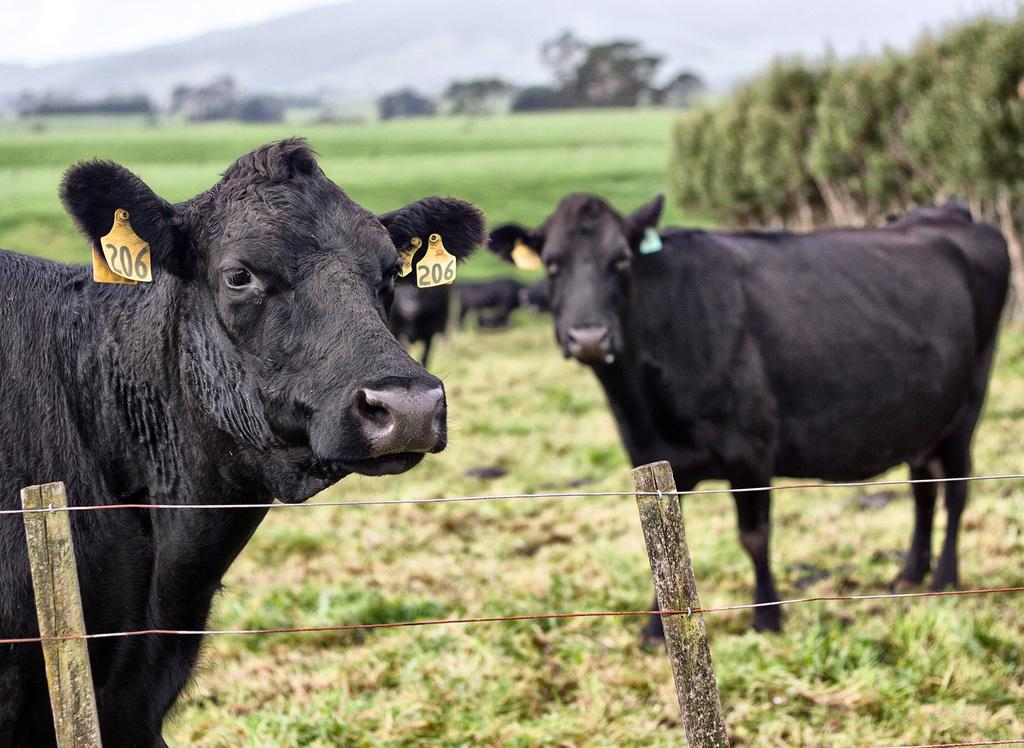What type of animals are in the image? There are buffaloes in the image. What distinguishing feature can be seen on the buffaloes? The buffaloes have tags on their ears. What can be seen at the bottom of the image? There are wooden poles at the bottom of the image. What is the condition of the background in the image? The background of the image is blurred. What type of vegetation is visible in the image? Grass is visible in the image. What else can be seen in the background of the image? There are trees in the background of the image. How many buffaloes are in the image? There are additional buffaloes in the image. What type of calendar is hanging on the tree in the image? There is no calendar present in the image; it features buffaloes with ear tags, wooden poles, and trees in the background. 